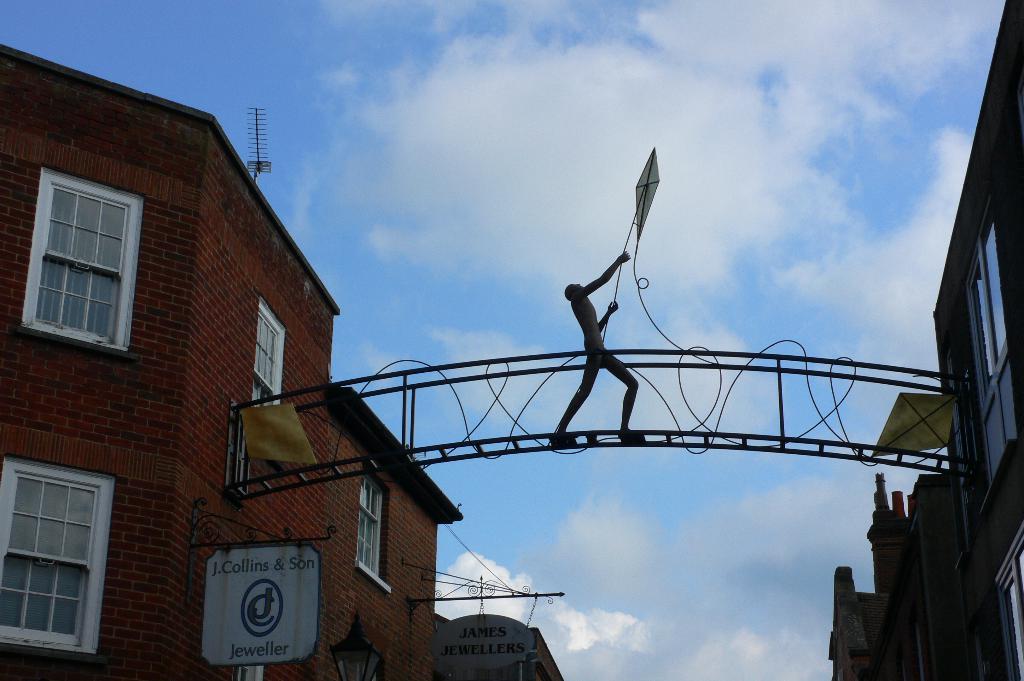How would you summarize this image in a sentence or two? In this image we can see an arch, boards, light poles, brick buildings, antenna and sky with clouds in the background. 